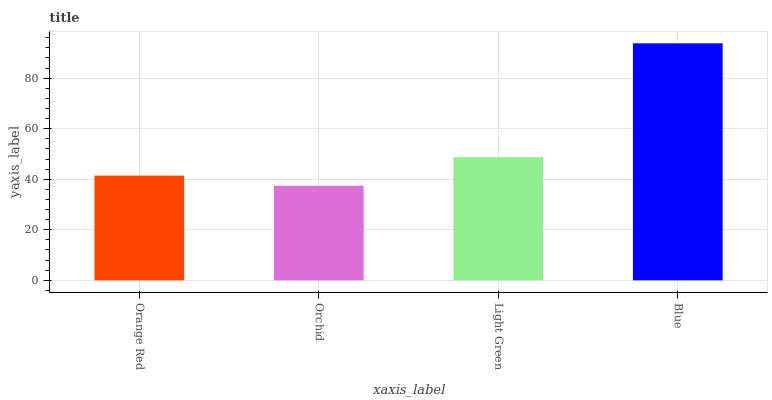Is Orchid the minimum?
Answer yes or no. Yes. Is Blue the maximum?
Answer yes or no. Yes. Is Light Green the minimum?
Answer yes or no. No. Is Light Green the maximum?
Answer yes or no. No. Is Light Green greater than Orchid?
Answer yes or no. Yes. Is Orchid less than Light Green?
Answer yes or no. Yes. Is Orchid greater than Light Green?
Answer yes or no. No. Is Light Green less than Orchid?
Answer yes or no. No. Is Light Green the high median?
Answer yes or no. Yes. Is Orange Red the low median?
Answer yes or no. Yes. Is Orange Red the high median?
Answer yes or no. No. Is Light Green the low median?
Answer yes or no. No. 